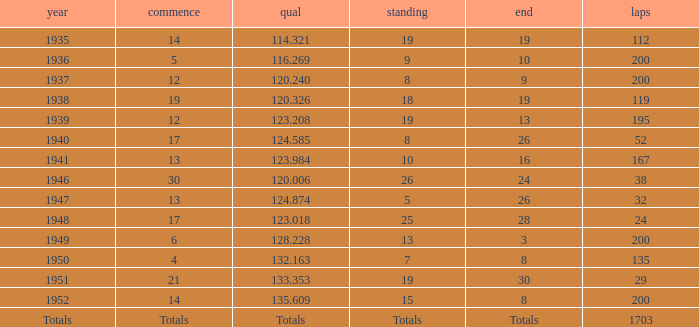With a Rank of 19, and a Start of 14, what was the finish? 19.0. 